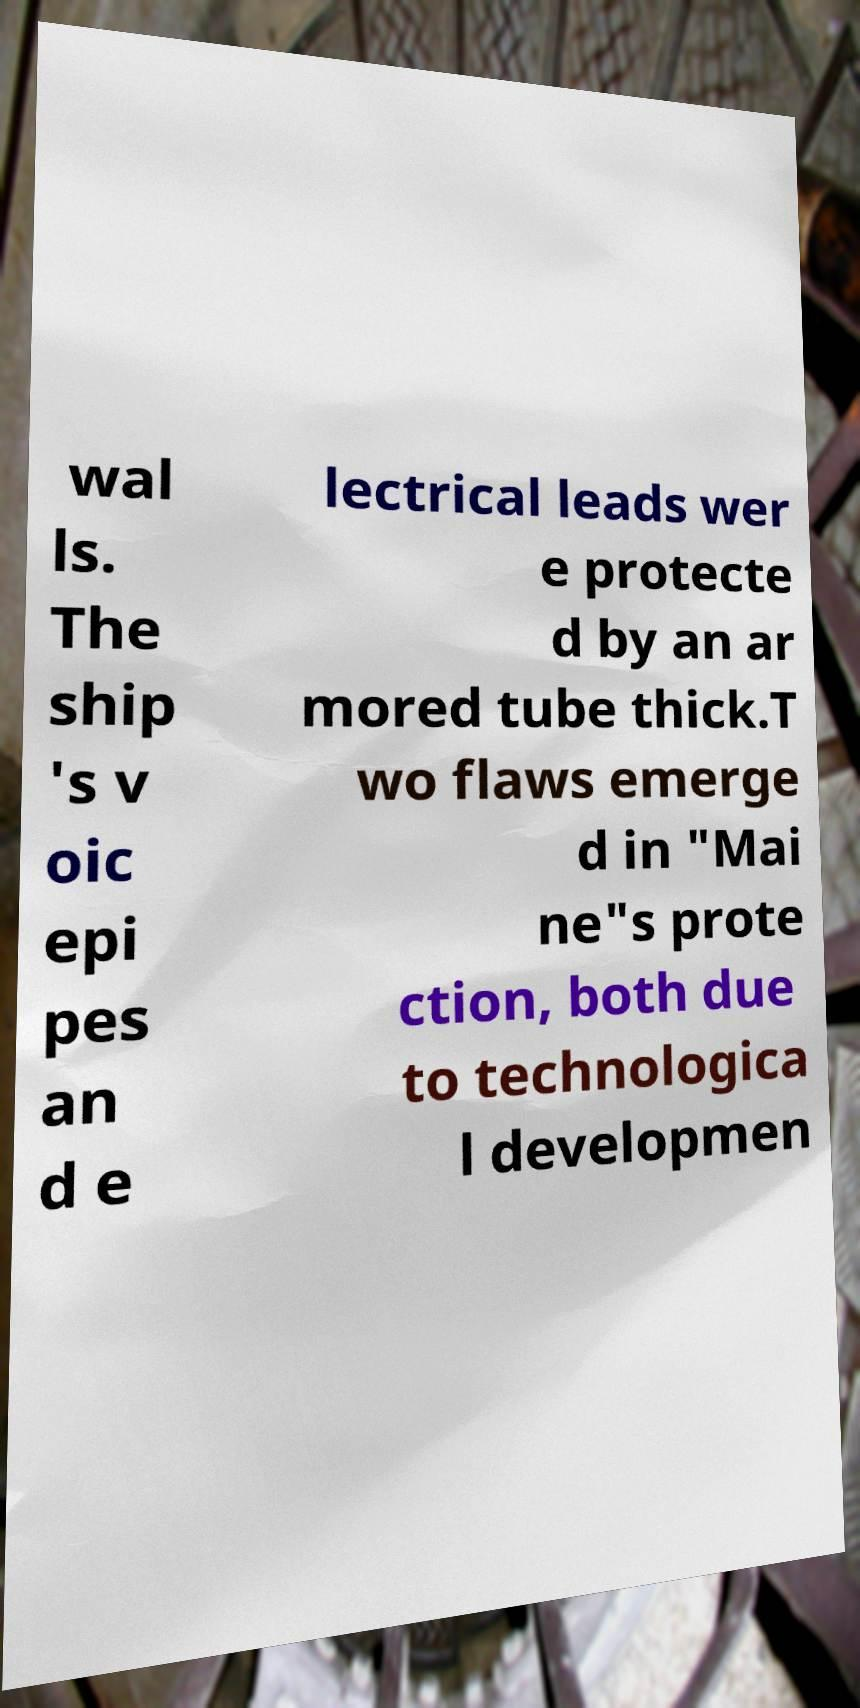Can you read and provide the text displayed in the image?This photo seems to have some interesting text. Can you extract and type it out for me? wal ls. The ship 's v oic epi pes an d e lectrical leads wer e protecte d by an ar mored tube thick.T wo flaws emerge d in "Mai ne"s prote ction, both due to technologica l developmen 